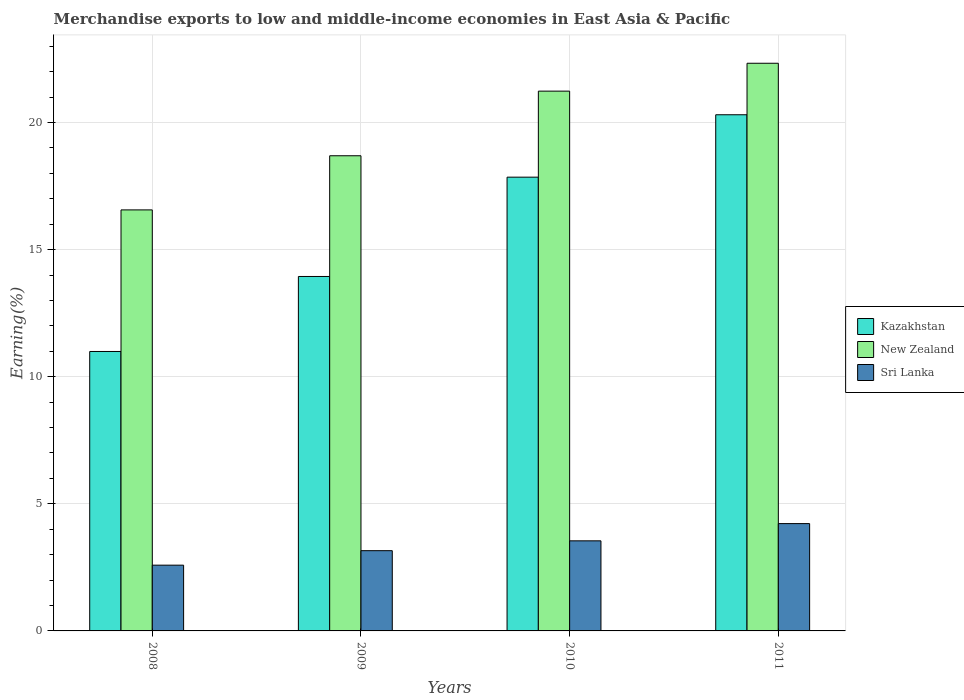How many different coloured bars are there?
Your answer should be compact. 3. How many groups of bars are there?
Your answer should be compact. 4. Are the number of bars per tick equal to the number of legend labels?
Give a very brief answer. Yes. How many bars are there on the 2nd tick from the left?
Provide a succinct answer. 3. What is the label of the 4th group of bars from the left?
Provide a short and direct response. 2011. What is the percentage of amount earned from merchandise exports in Kazakhstan in 2008?
Keep it short and to the point. 10.99. Across all years, what is the maximum percentage of amount earned from merchandise exports in New Zealand?
Your answer should be very brief. 22.33. Across all years, what is the minimum percentage of amount earned from merchandise exports in Kazakhstan?
Provide a succinct answer. 10.99. In which year was the percentage of amount earned from merchandise exports in Kazakhstan maximum?
Make the answer very short. 2011. What is the total percentage of amount earned from merchandise exports in New Zealand in the graph?
Ensure brevity in your answer.  78.82. What is the difference between the percentage of amount earned from merchandise exports in Sri Lanka in 2008 and that in 2009?
Your answer should be compact. -0.57. What is the difference between the percentage of amount earned from merchandise exports in Kazakhstan in 2011 and the percentage of amount earned from merchandise exports in Sri Lanka in 2009?
Your response must be concise. 17.15. What is the average percentage of amount earned from merchandise exports in Sri Lanka per year?
Make the answer very short. 3.38. In the year 2010, what is the difference between the percentage of amount earned from merchandise exports in Sri Lanka and percentage of amount earned from merchandise exports in New Zealand?
Provide a succinct answer. -17.69. What is the ratio of the percentage of amount earned from merchandise exports in Kazakhstan in 2009 to that in 2010?
Offer a terse response. 0.78. What is the difference between the highest and the second highest percentage of amount earned from merchandise exports in New Zealand?
Provide a short and direct response. 1.1. What is the difference between the highest and the lowest percentage of amount earned from merchandise exports in New Zealand?
Provide a succinct answer. 5.77. In how many years, is the percentage of amount earned from merchandise exports in Kazakhstan greater than the average percentage of amount earned from merchandise exports in Kazakhstan taken over all years?
Provide a succinct answer. 2. What does the 3rd bar from the left in 2011 represents?
Your answer should be compact. Sri Lanka. What does the 1st bar from the right in 2010 represents?
Provide a short and direct response. Sri Lanka. Is it the case that in every year, the sum of the percentage of amount earned from merchandise exports in New Zealand and percentage of amount earned from merchandise exports in Kazakhstan is greater than the percentage of amount earned from merchandise exports in Sri Lanka?
Give a very brief answer. Yes. Are all the bars in the graph horizontal?
Make the answer very short. No. How many years are there in the graph?
Offer a very short reply. 4. What is the difference between two consecutive major ticks on the Y-axis?
Provide a short and direct response. 5. Where does the legend appear in the graph?
Keep it short and to the point. Center right. How are the legend labels stacked?
Your response must be concise. Vertical. What is the title of the graph?
Your answer should be very brief. Merchandise exports to low and middle-income economies in East Asia & Pacific. What is the label or title of the X-axis?
Offer a terse response. Years. What is the label or title of the Y-axis?
Offer a terse response. Earning(%). What is the Earning(%) in Kazakhstan in 2008?
Make the answer very short. 10.99. What is the Earning(%) of New Zealand in 2008?
Your answer should be very brief. 16.56. What is the Earning(%) of Sri Lanka in 2008?
Ensure brevity in your answer.  2.59. What is the Earning(%) of Kazakhstan in 2009?
Make the answer very short. 13.94. What is the Earning(%) of New Zealand in 2009?
Provide a short and direct response. 18.69. What is the Earning(%) of Sri Lanka in 2009?
Ensure brevity in your answer.  3.16. What is the Earning(%) of Kazakhstan in 2010?
Offer a very short reply. 17.85. What is the Earning(%) in New Zealand in 2010?
Offer a very short reply. 21.24. What is the Earning(%) of Sri Lanka in 2010?
Ensure brevity in your answer.  3.54. What is the Earning(%) of Kazakhstan in 2011?
Keep it short and to the point. 20.31. What is the Earning(%) in New Zealand in 2011?
Give a very brief answer. 22.33. What is the Earning(%) of Sri Lanka in 2011?
Your response must be concise. 4.22. Across all years, what is the maximum Earning(%) in Kazakhstan?
Provide a short and direct response. 20.31. Across all years, what is the maximum Earning(%) of New Zealand?
Offer a very short reply. 22.33. Across all years, what is the maximum Earning(%) of Sri Lanka?
Provide a succinct answer. 4.22. Across all years, what is the minimum Earning(%) of Kazakhstan?
Provide a short and direct response. 10.99. Across all years, what is the minimum Earning(%) in New Zealand?
Your answer should be very brief. 16.56. Across all years, what is the minimum Earning(%) in Sri Lanka?
Make the answer very short. 2.59. What is the total Earning(%) of Kazakhstan in the graph?
Your response must be concise. 63.09. What is the total Earning(%) of New Zealand in the graph?
Offer a terse response. 78.82. What is the total Earning(%) of Sri Lanka in the graph?
Make the answer very short. 13.51. What is the difference between the Earning(%) in Kazakhstan in 2008 and that in 2009?
Make the answer very short. -2.95. What is the difference between the Earning(%) in New Zealand in 2008 and that in 2009?
Your response must be concise. -2.13. What is the difference between the Earning(%) in Sri Lanka in 2008 and that in 2009?
Your answer should be compact. -0.57. What is the difference between the Earning(%) of Kazakhstan in 2008 and that in 2010?
Make the answer very short. -6.86. What is the difference between the Earning(%) of New Zealand in 2008 and that in 2010?
Provide a short and direct response. -4.67. What is the difference between the Earning(%) of Sri Lanka in 2008 and that in 2010?
Ensure brevity in your answer.  -0.96. What is the difference between the Earning(%) in Kazakhstan in 2008 and that in 2011?
Keep it short and to the point. -9.31. What is the difference between the Earning(%) of New Zealand in 2008 and that in 2011?
Ensure brevity in your answer.  -5.77. What is the difference between the Earning(%) of Sri Lanka in 2008 and that in 2011?
Ensure brevity in your answer.  -1.64. What is the difference between the Earning(%) of Kazakhstan in 2009 and that in 2010?
Your answer should be compact. -3.91. What is the difference between the Earning(%) in New Zealand in 2009 and that in 2010?
Keep it short and to the point. -2.54. What is the difference between the Earning(%) in Sri Lanka in 2009 and that in 2010?
Your answer should be very brief. -0.39. What is the difference between the Earning(%) of Kazakhstan in 2009 and that in 2011?
Your response must be concise. -6.36. What is the difference between the Earning(%) of New Zealand in 2009 and that in 2011?
Your response must be concise. -3.64. What is the difference between the Earning(%) of Sri Lanka in 2009 and that in 2011?
Ensure brevity in your answer.  -1.07. What is the difference between the Earning(%) in Kazakhstan in 2010 and that in 2011?
Your answer should be compact. -2.46. What is the difference between the Earning(%) of New Zealand in 2010 and that in 2011?
Make the answer very short. -1.1. What is the difference between the Earning(%) in Sri Lanka in 2010 and that in 2011?
Give a very brief answer. -0.68. What is the difference between the Earning(%) in Kazakhstan in 2008 and the Earning(%) in New Zealand in 2009?
Keep it short and to the point. -7.7. What is the difference between the Earning(%) in Kazakhstan in 2008 and the Earning(%) in Sri Lanka in 2009?
Keep it short and to the point. 7.84. What is the difference between the Earning(%) of New Zealand in 2008 and the Earning(%) of Sri Lanka in 2009?
Offer a very short reply. 13.41. What is the difference between the Earning(%) in Kazakhstan in 2008 and the Earning(%) in New Zealand in 2010?
Give a very brief answer. -10.24. What is the difference between the Earning(%) of Kazakhstan in 2008 and the Earning(%) of Sri Lanka in 2010?
Make the answer very short. 7.45. What is the difference between the Earning(%) of New Zealand in 2008 and the Earning(%) of Sri Lanka in 2010?
Your answer should be compact. 13.02. What is the difference between the Earning(%) of Kazakhstan in 2008 and the Earning(%) of New Zealand in 2011?
Provide a short and direct response. -11.34. What is the difference between the Earning(%) in Kazakhstan in 2008 and the Earning(%) in Sri Lanka in 2011?
Make the answer very short. 6.77. What is the difference between the Earning(%) in New Zealand in 2008 and the Earning(%) in Sri Lanka in 2011?
Offer a very short reply. 12.34. What is the difference between the Earning(%) of Kazakhstan in 2009 and the Earning(%) of New Zealand in 2010?
Your answer should be very brief. -7.29. What is the difference between the Earning(%) of Kazakhstan in 2009 and the Earning(%) of Sri Lanka in 2010?
Offer a very short reply. 10.4. What is the difference between the Earning(%) of New Zealand in 2009 and the Earning(%) of Sri Lanka in 2010?
Your response must be concise. 15.15. What is the difference between the Earning(%) in Kazakhstan in 2009 and the Earning(%) in New Zealand in 2011?
Offer a terse response. -8.39. What is the difference between the Earning(%) of Kazakhstan in 2009 and the Earning(%) of Sri Lanka in 2011?
Offer a terse response. 9.72. What is the difference between the Earning(%) in New Zealand in 2009 and the Earning(%) in Sri Lanka in 2011?
Provide a short and direct response. 14.47. What is the difference between the Earning(%) in Kazakhstan in 2010 and the Earning(%) in New Zealand in 2011?
Keep it short and to the point. -4.48. What is the difference between the Earning(%) in Kazakhstan in 2010 and the Earning(%) in Sri Lanka in 2011?
Make the answer very short. 13.63. What is the difference between the Earning(%) of New Zealand in 2010 and the Earning(%) of Sri Lanka in 2011?
Your answer should be very brief. 17.01. What is the average Earning(%) in Kazakhstan per year?
Keep it short and to the point. 15.77. What is the average Earning(%) in New Zealand per year?
Ensure brevity in your answer.  19.71. What is the average Earning(%) of Sri Lanka per year?
Your answer should be compact. 3.38. In the year 2008, what is the difference between the Earning(%) of Kazakhstan and Earning(%) of New Zealand?
Offer a very short reply. -5.57. In the year 2008, what is the difference between the Earning(%) in Kazakhstan and Earning(%) in Sri Lanka?
Keep it short and to the point. 8.41. In the year 2008, what is the difference between the Earning(%) in New Zealand and Earning(%) in Sri Lanka?
Make the answer very short. 13.98. In the year 2009, what is the difference between the Earning(%) of Kazakhstan and Earning(%) of New Zealand?
Ensure brevity in your answer.  -4.75. In the year 2009, what is the difference between the Earning(%) in Kazakhstan and Earning(%) in Sri Lanka?
Make the answer very short. 10.79. In the year 2009, what is the difference between the Earning(%) of New Zealand and Earning(%) of Sri Lanka?
Provide a short and direct response. 15.54. In the year 2010, what is the difference between the Earning(%) in Kazakhstan and Earning(%) in New Zealand?
Ensure brevity in your answer.  -3.38. In the year 2010, what is the difference between the Earning(%) of Kazakhstan and Earning(%) of Sri Lanka?
Your response must be concise. 14.31. In the year 2010, what is the difference between the Earning(%) in New Zealand and Earning(%) in Sri Lanka?
Provide a succinct answer. 17.69. In the year 2011, what is the difference between the Earning(%) in Kazakhstan and Earning(%) in New Zealand?
Provide a short and direct response. -2.03. In the year 2011, what is the difference between the Earning(%) of Kazakhstan and Earning(%) of Sri Lanka?
Offer a very short reply. 16.08. In the year 2011, what is the difference between the Earning(%) in New Zealand and Earning(%) in Sri Lanka?
Ensure brevity in your answer.  18.11. What is the ratio of the Earning(%) in Kazakhstan in 2008 to that in 2009?
Make the answer very short. 0.79. What is the ratio of the Earning(%) in New Zealand in 2008 to that in 2009?
Provide a succinct answer. 0.89. What is the ratio of the Earning(%) of Sri Lanka in 2008 to that in 2009?
Your response must be concise. 0.82. What is the ratio of the Earning(%) in Kazakhstan in 2008 to that in 2010?
Your answer should be very brief. 0.62. What is the ratio of the Earning(%) of New Zealand in 2008 to that in 2010?
Make the answer very short. 0.78. What is the ratio of the Earning(%) of Sri Lanka in 2008 to that in 2010?
Make the answer very short. 0.73. What is the ratio of the Earning(%) of Kazakhstan in 2008 to that in 2011?
Your answer should be compact. 0.54. What is the ratio of the Earning(%) in New Zealand in 2008 to that in 2011?
Your response must be concise. 0.74. What is the ratio of the Earning(%) in Sri Lanka in 2008 to that in 2011?
Provide a short and direct response. 0.61. What is the ratio of the Earning(%) of Kazakhstan in 2009 to that in 2010?
Make the answer very short. 0.78. What is the ratio of the Earning(%) in New Zealand in 2009 to that in 2010?
Give a very brief answer. 0.88. What is the ratio of the Earning(%) of Sri Lanka in 2009 to that in 2010?
Make the answer very short. 0.89. What is the ratio of the Earning(%) in Kazakhstan in 2009 to that in 2011?
Your answer should be very brief. 0.69. What is the ratio of the Earning(%) in New Zealand in 2009 to that in 2011?
Your answer should be compact. 0.84. What is the ratio of the Earning(%) in Sri Lanka in 2009 to that in 2011?
Your response must be concise. 0.75. What is the ratio of the Earning(%) of Kazakhstan in 2010 to that in 2011?
Provide a succinct answer. 0.88. What is the ratio of the Earning(%) in New Zealand in 2010 to that in 2011?
Make the answer very short. 0.95. What is the ratio of the Earning(%) of Sri Lanka in 2010 to that in 2011?
Ensure brevity in your answer.  0.84. What is the difference between the highest and the second highest Earning(%) of Kazakhstan?
Your answer should be very brief. 2.46. What is the difference between the highest and the second highest Earning(%) of New Zealand?
Ensure brevity in your answer.  1.1. What is the difference between the highest and the second highest Earning(%) of Sri Lanka?
Make the answer very short. 0.68. What is the difference between the highest and the lowest Earning(%) of Kazakhstan?
Make the answer very short. 9.31. What is the difference between the highest and the lowest Earning(%) of New Zealand?
Offer a terse response. 5.77. What is the difference between the highest and the lowest Earning(%) in Sri Lanka?
Your response must be concise. 1.64. 